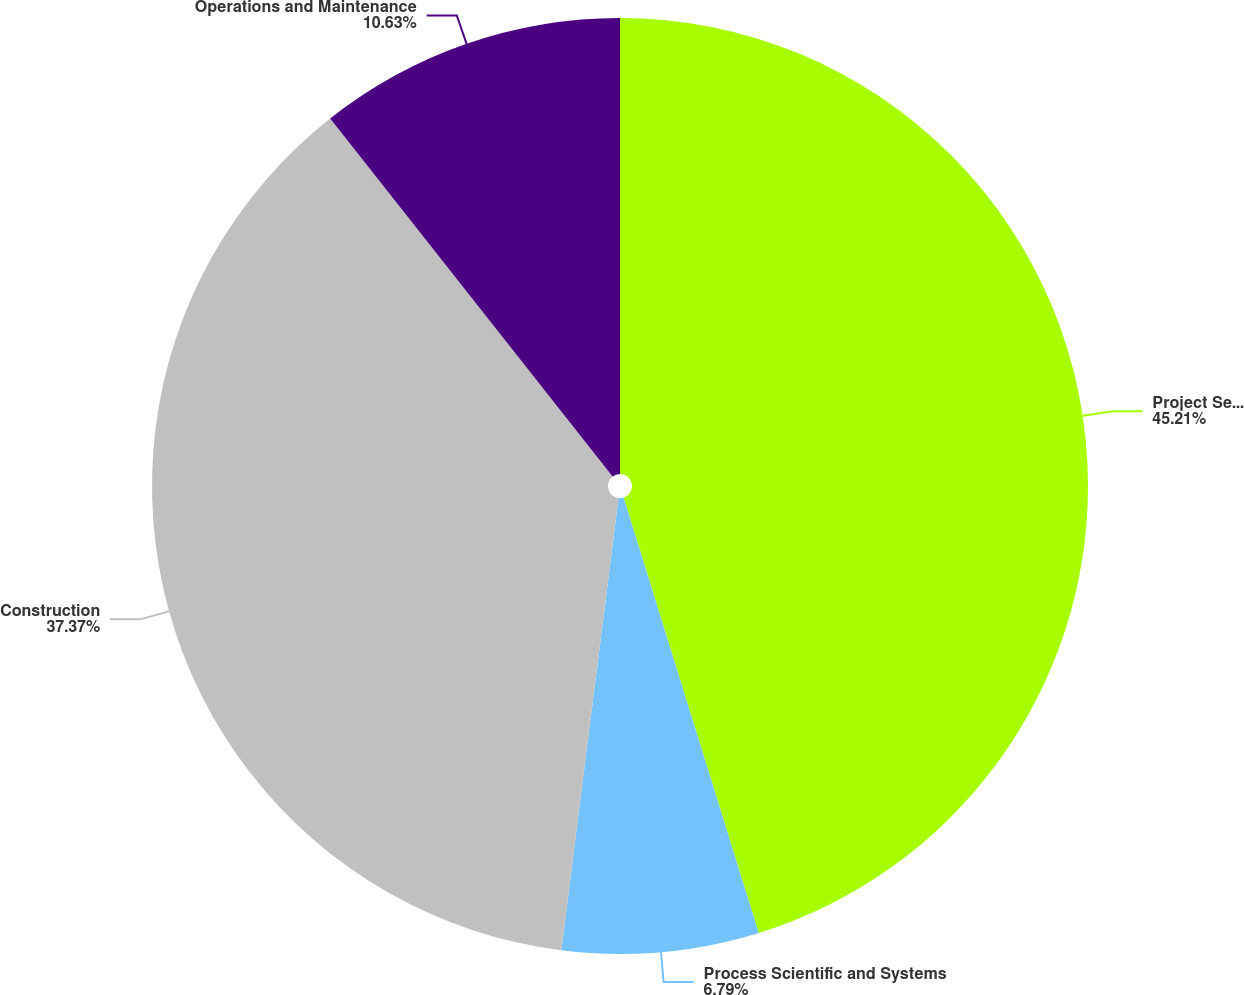<chart> <loc_0><loc_0><loc_500><loc_500><pie_chart><fcel>Project Services<fcel>Process Scientific and Systems<fcel>Construction<fcel>Operations and Maintenance<nl><fcel>45.21%<fcel>6.79%<fcel>37.37%<fcel>10.63%<nl></chart> 